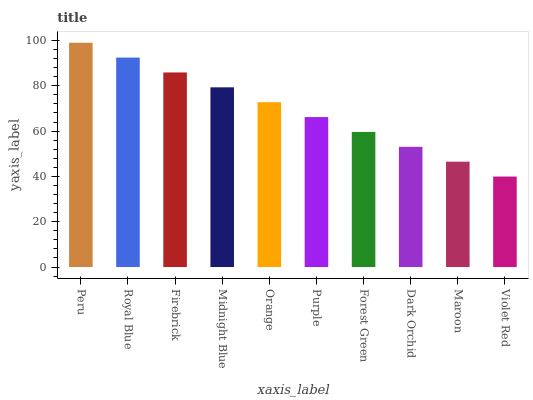Is Violet Red the minimum?
Answer yes or no. Yes. Is Peru the maximum?
Answer yes or no. Yes. Is Royal Blue the minimum?
Answer yes or no. No. Is Royal Blue the maximum?
Answer yes or no. No. Is Peru greater than Royal Blue?
Answer yes or no. Yes. Is Royal Blue less than Peru?
Answer yes or no. Yes. Is Royal Blue greater than Peru?
Answer yes or no. No. Is Peru less than Royal Blue?
Answer yes or no. No. Is Orange the high median?
Answer yes or no. Yes. Is Purple the low median?
Answer yes or no. Yes. Is Peru the high median?
Answer yes or no. No. Is Firebrick the low median?
Answer yes or no. No. 